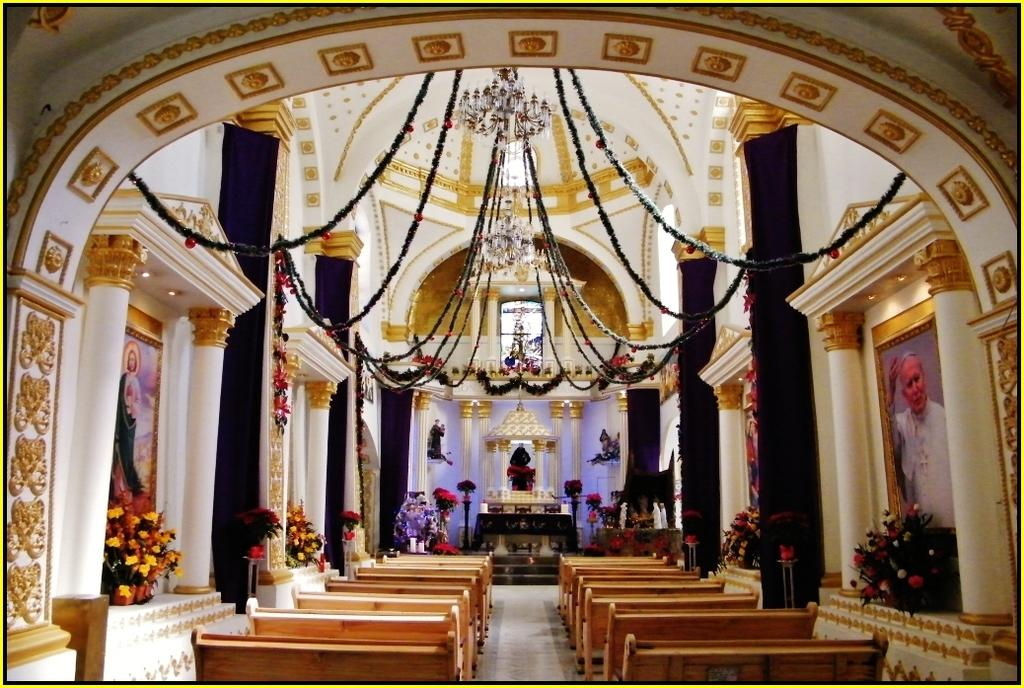What type of furniture is on the floor in the image? There are benches on the floor in the image. What can be seen on the left and right side of the image? Flower vases are present on a platform on the left and right side. What architectural elements are visible in the image? There are pillars in the image. What is on the wall in the image? Designs are visible on the wall, and frames are present as well. What is at the top of the image? Decorative items are at the top of the image. What disease is being treated in the image? There is no indication of a disease or medical treatment in the image. How many giants are present in the image? There are no giants present in the image. 